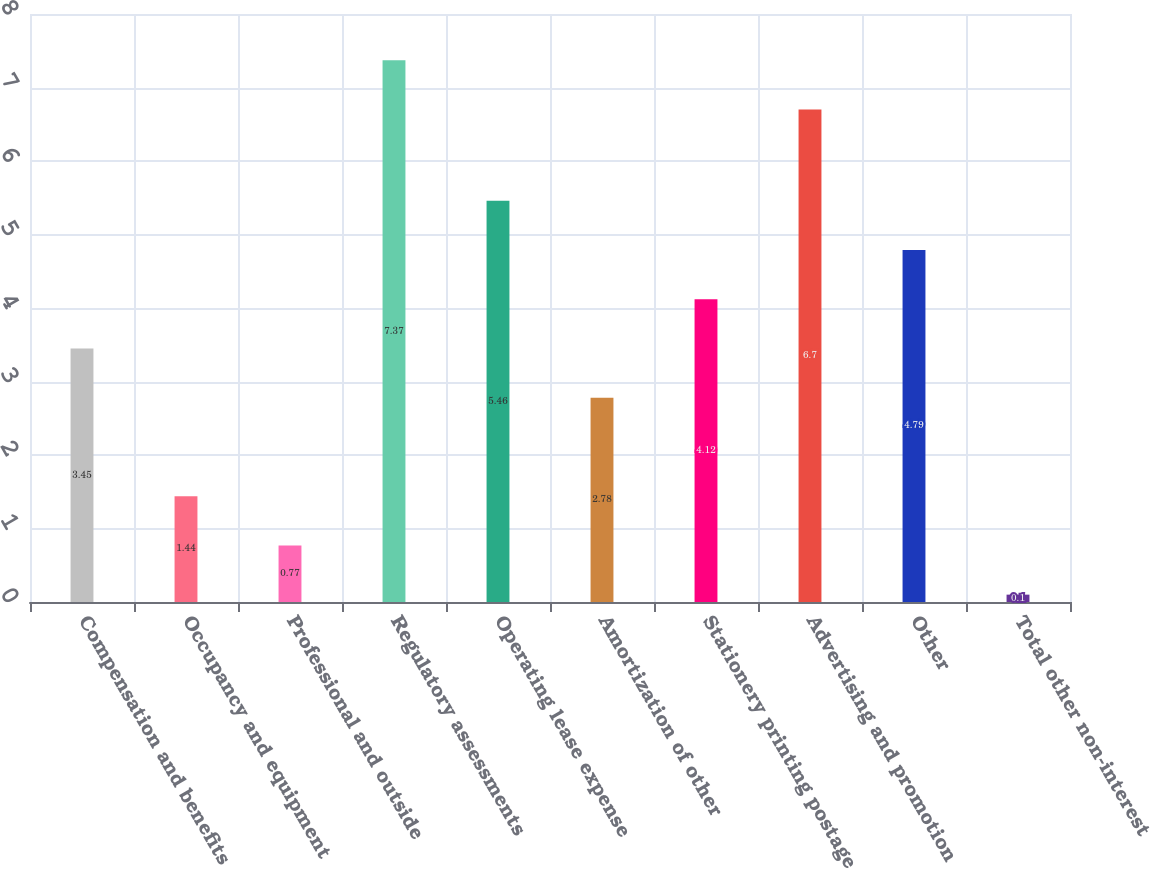<chart> <loc_0><loc_0><loc_500><loc_500><bar_chart><fcel>Compensation and benefits<fcel>Occupancy and equipment<fcel>Professional and outside<fcel>Regulatory assessments<fcel>Operating lease expense<fcel>Amortization of other<fcel>Stationery printing postage<fcel>Advertising and promotion<fcel>Other<fcel>Total other non-interest<nl><fcel>3.45<fcel>1.44<fcel>0.77<fcel>7.37<fcel>5.46<fcel>2.78<fcel>4.12<fcel>6.7<fcel>4.79<fcel>0.1<nl></chart> 